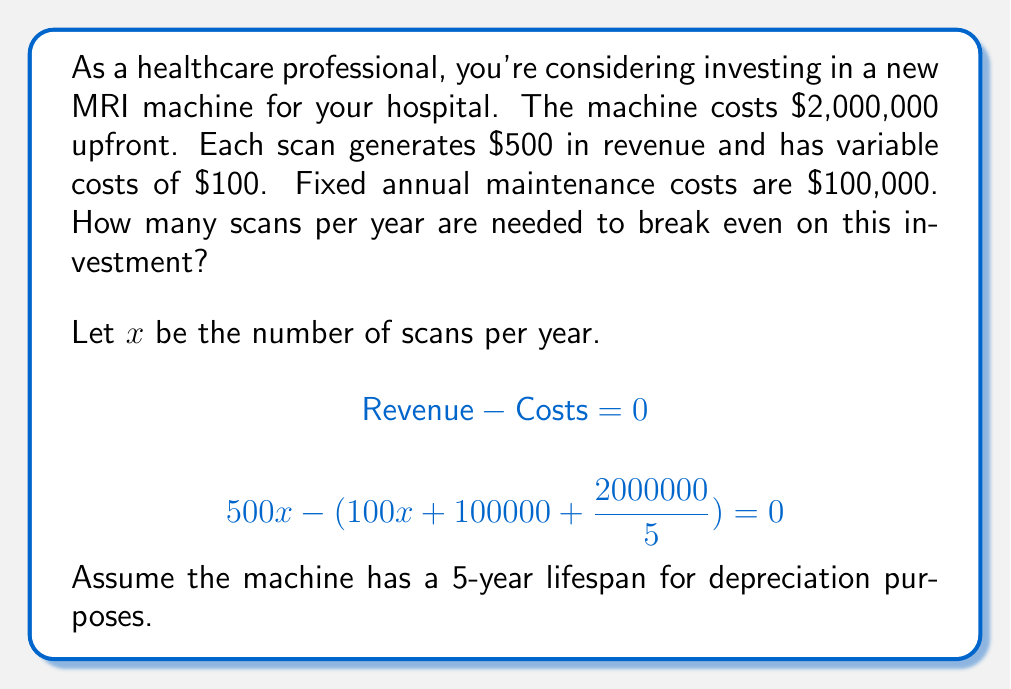Can you answer this question? To find the break-even point, we need to set up an equation where total revenue equals total costs.

1) Revenue per scan: $500
2) Variable cost per scan: $100
3) Fixed annual costs: $100,000 maintenance + $400,000 depreciation (2,000,000 / 5 years)

Let's set up the equation:

$$500x = 100x + 100000 + 400000$$

Now, let's solve for $x$:

$$500x = 100x + 500000$$
$$400x = 500000$$
$$x = \frac{500000}{400} = 1250$$

To verify:
Revenue: $500 * 1250 = 625000$
Costs: $(100 * 1250) + 100000 + 400000 = 625000$

Therefore, the hospital needs to perform 1,250 scans per year to break even on this investment.
Answer: 1,250 scans per year 